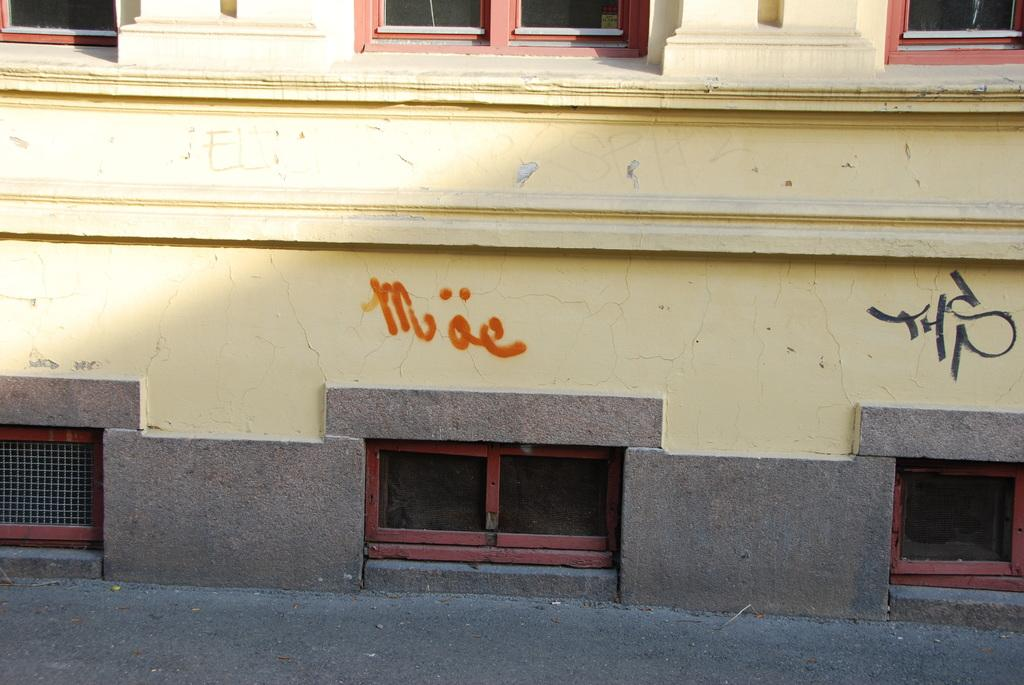What type of structure is present in the image? There is a building in the image. What color is the building? The building is yellow in color. What material is used for the windows on the building? The windows on the building are made of glass. What type of wood is used to build the corn silo in the image? There is no corn silo present in the image, and therefore no wood or corn can be observed. 